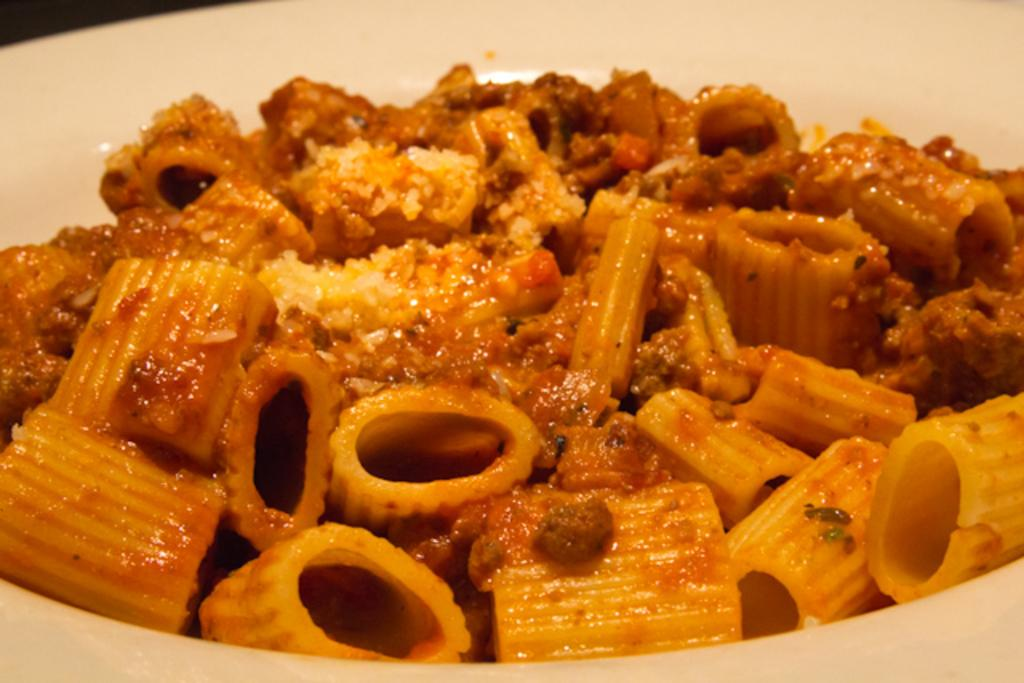What type of bowl is in the image? There is a white bowl in the image. What is inside the bowl? There is pasta in the bowl. How is the pasta described? The pasta is described as delicious. How many trees are visible in the image? There are no trees visible in the image; it features a white bowl with pasta. What type of leaf is used as a decoration on the desk in the image? There is no desk or leaf present in the image. 